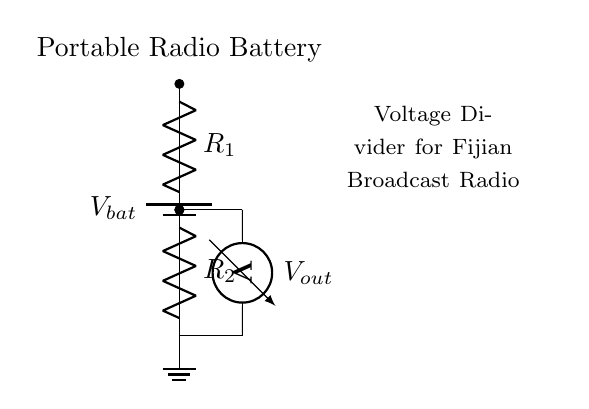What type of circuit is shown? The diagram represents a voltage divider circuit, which is used to obtain a fraction of the input voltage. The presence of two resistors in series indicates this is indeed a voltage divider.
Answer: Voltage divider What is the output voltage symbol in this circuit? The output voltage is denoted by V out, which is connected across the second resistor and the voltmeter in this voltage divider setup.
Answer: V out How many resistors are in this circuit? There are two resistors present, labeled R1 and R2, which create the voltage division for measuring the battery voltage.
Answer: Two What component is used to measure the output voltage? The output voltage is measured using a voltmeter, which is indicated by the symbol in the circuit diagram positioned parallel to the second resistor R2.
Answer: Voltmeter What happens to the voltage if R1 is increased? Increasing R1 will raise the voltage across R1, reducing V out because the voltage drop across R2 will decrease, demonstrating the relationship defined by the voltage divider equation.
Answer: V out decreases What is the purpose of the ground in this circuit? The ground serves as a reference point for the voltage measurements, ensuring that the circuit operates correctly and that the voltmeter has a direct comparison for its measurements of V out.
Answer: Reference point What does the label "Portable Radio Battery" indicate? This label shows that the battery is used to power the portable radio's circuit, and the measurement conducted by the voltage divider will help monitor the battery voltage, ensuring proper operation for listening to Fijian broadcasts.
Answer: Battery type 